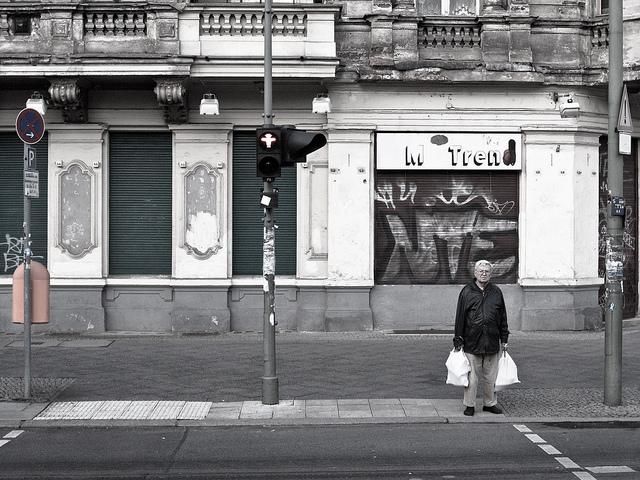What is he waiting for?
Give a very brief answer. Bus. What is the man carrying?
Write a very short answer. Bags. Is he carrying plastic bags?
Be succinct. Yes. 